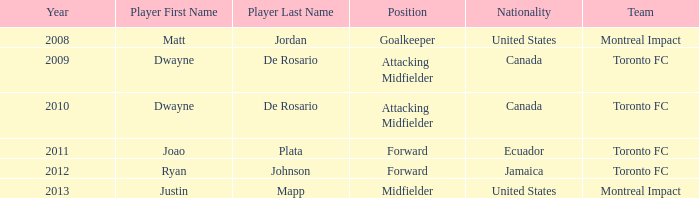What's the nationality of Montreal Impact with Justin Mapp Category:articles with hcards as the player? United States. 